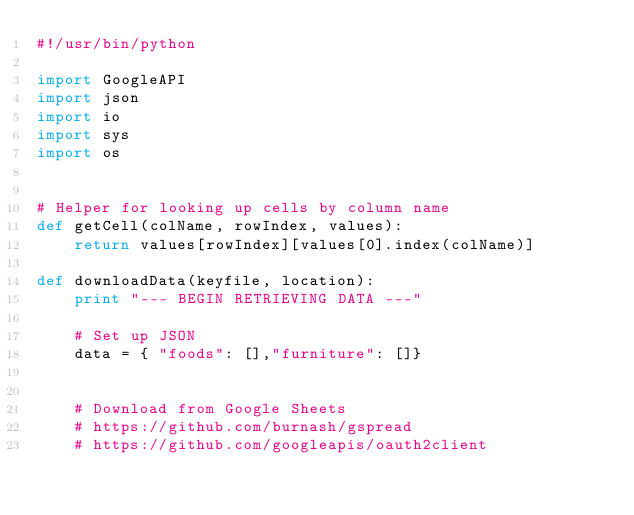<code> <loc_0><loc_0><loc_500><loc_500><_Python_>#!/usr/bin/python

import GoogleAPI
import json
import io
import sys
import os


# Helper for looking up cells by column name
def getCell(colName, rowIndex, values):
    return values[rowIndex][values[0].index(colName)]

def downloadData(keyfile, location):
    print "--- BEGIN RETRIEVING DATA ---"

    # Set up JSON
    data = { "foods": [],"furniture": []}
 

    # Download from Google Sheets
    # https://github.com/burnash/gspread
    # https://github.com/googleapis/oauth2client</code> 